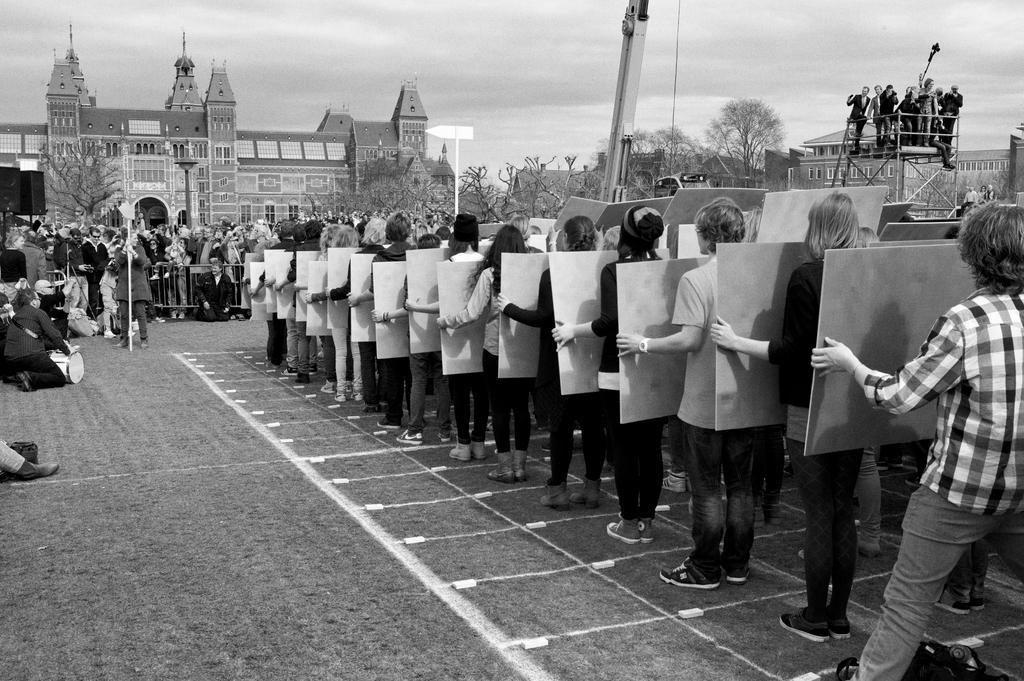In one or two sentences, can you explain what this image depicts? In this picture there are few persons holding an object in their hands and there are few other people standing in front of them and there are buildings and trees in the background. 